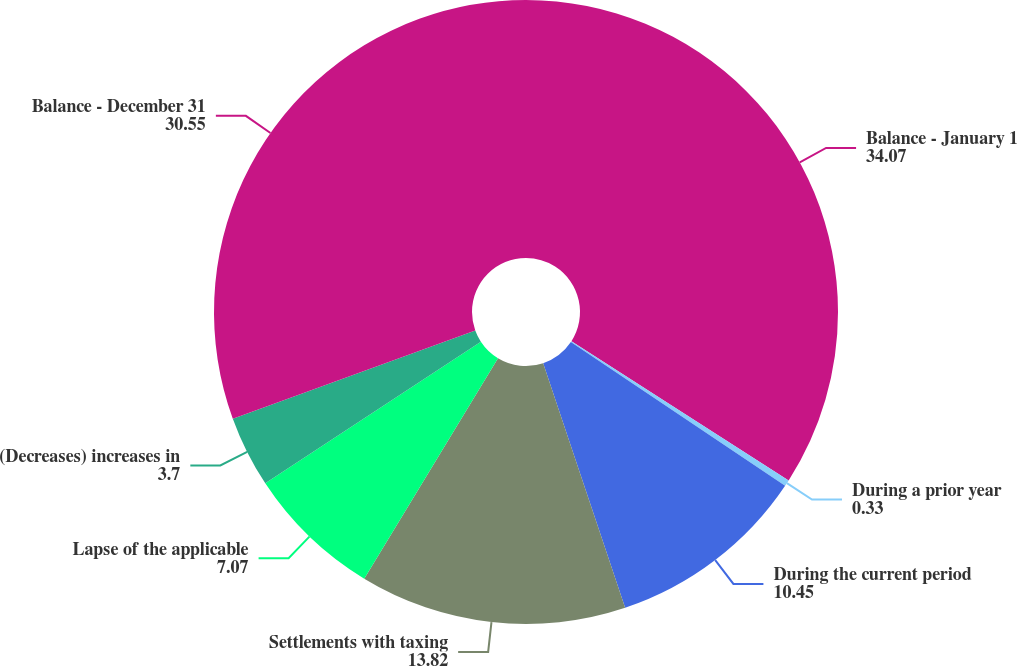Convert chart to OTSL. <chart><loc_0><loc_0><loc_500><loc_500><pie_chart><fcel>Balance - January 1<fcel>During a prior year<fcel>During the current period<fcel>Settlements with taxing<fcel>Lapse of the applicable<fcel>(Decreases) increases in<fcel>Balance - December 31<nl><fcel>34.07%<fcel>0.33%<fcel>10.45%<fcel>13.82%<fcel>7.07%<fcel>3.7%<fcel>30.55%<nl></chart> 